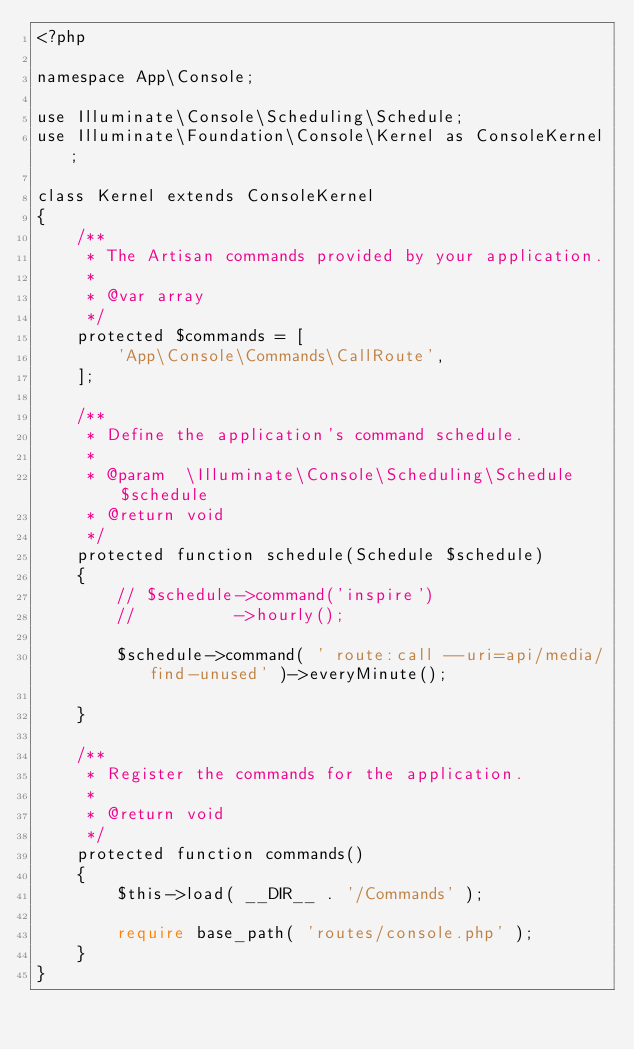<code> <loc_0><loc_0><loc_500><loc_500><_PHP_><?php

namespace App\Console;

use Illuminate\Console\Scheduling\Schedule;
use Illuminate\Foundation\Console\Kernel as ConsoleKernel;

class Kernel extends ConsoleKernel
{
    /**
     * The Artisan commands provided by your application.
     *
     * @var array
     */
    protected $commands = [
        'App\Console\Commands\CallRoute',
    ];

    /**
     * Define the application's command schedule.
     *
     * @param  \Illuminate\Console\Scheduling\Schedule $schedule
     * @return void
     */
    protected function schedule(Schedule $schedule)
    {
        // $schedule->command('inspire')
        //          ->hourly();

        $schedule->command( ' route:call --uri=api/media/find-unused' )->everyMinute();

    }

    /**
     * Register the commands for the application.
     *
     * @return void
     */
    protected function commands()
    {
        $this->load( __DIR__ . '/Commands' );

        require base_path( 'routes/console.php' );
    }
}
</code> 